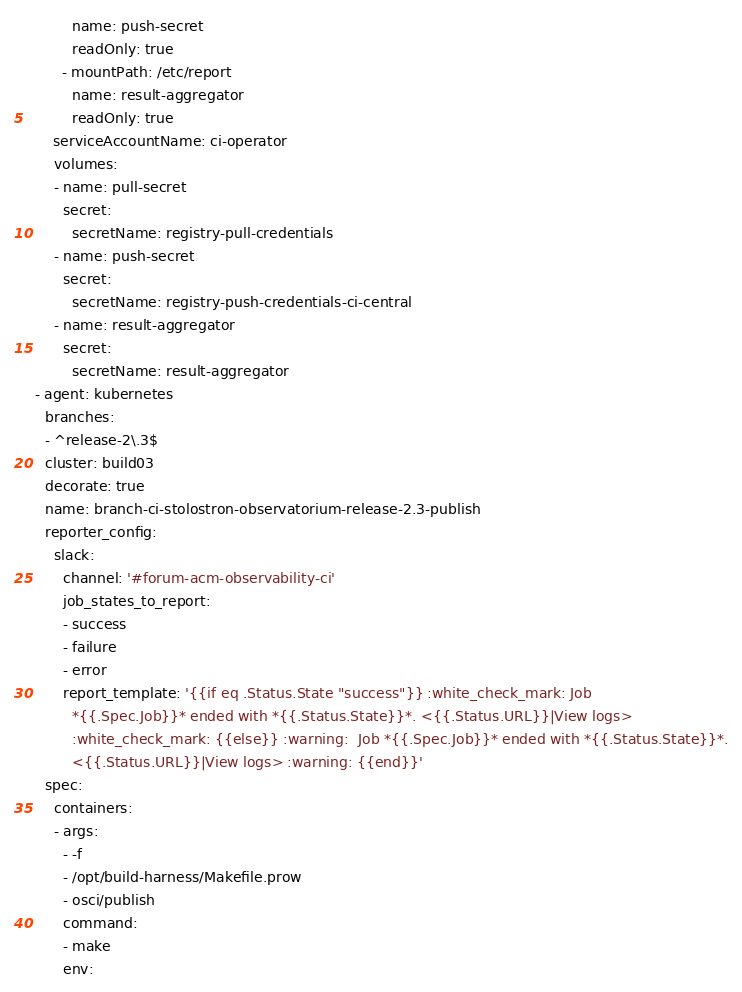<code> <loc_0><loc_0><loc_500><loc_500><_YAML_>          name: push-secret
          readOnly: true
        - mountPath: /etc/report
          name: result-aggregator
          readOnly: true
      serviceAccountName: ci-operator
      volumes:
      - name: pull-secret
        secret:
          secretName: registry-pull-credentials
      - name: push-secret
        secret:
          secretName: registry-push-credentials-ci-central
      - name: result-aggregator
        secret:
          secretName: result-aggregator
  - agent: kubernetes
    branches:
    - ^release-2\.3$
    cluster: build03
    decorate: true
    name: branch-ci-stolostron-observatorium-release-2.3-publish
    reporter_config:
      slack:
        channel: '#forum-acm-observability-ci'
        job_states_to_report:
        - success
        - failure
        - error
        report_template: '{{if eq .Status.State "success"}} :white_check_mark: Job
          *{{.Spec.Job}}* ended with *{{.Status.State}}*. <{{.Status.URL}}|View logs>
          :white_check_mark: {{else}} :warning:  Job *{{.Spec.Job}}* ended with *{{.Status.State}}*.
          <{{.Status.URL}}|View logs> :warning: {{end}}'
    spec:
      containers:
      - args:
        - -f
        - /opt/build-harness/Makefile.prow
        - osci/publish
        command:
        - make
        env:</code> 